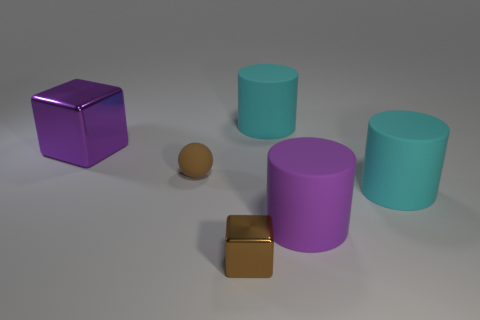Is there any other thing of the same color as the small block?
Give a very brief answer. Yes. There is a small matte thing; is it the same color as the shiny thing that is to the right of the brown sphere?
Ensure brevity in your answer.  Yes. There is a rubber sphere that is the same color as the small metal block; what size is it?
Make the answer very short. Small. There is a cylinder that is the same color as the big shiny object; what material is it?
Keep it short and to the point. Rubber. Is there a big matte cylinder that has the same color as the large metallic thing?
Keep it short and to the point. Yes. How many other objects are there of the same color as the matte sphere?
Provide a succinct answer. 1. Are there any large yellow things?
Provide a succinct answer. No. What number of other objects are the same material as the big cube?
Offer a very short reply. 1. What material is the sphere that is the same size as the brown metallic block?
Offer a very short reply. Rubber. Do the big purple object that is left of the purple cylinder and the tiny brown metallic object have the same shape?
Your response must be concise. Yes. 